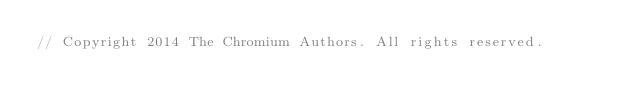<code> <loc_0><loc_0><loc_500><loc_500><_C++_>// Copyright 2014 The Chromium Authors. All rights reserved.</code> 